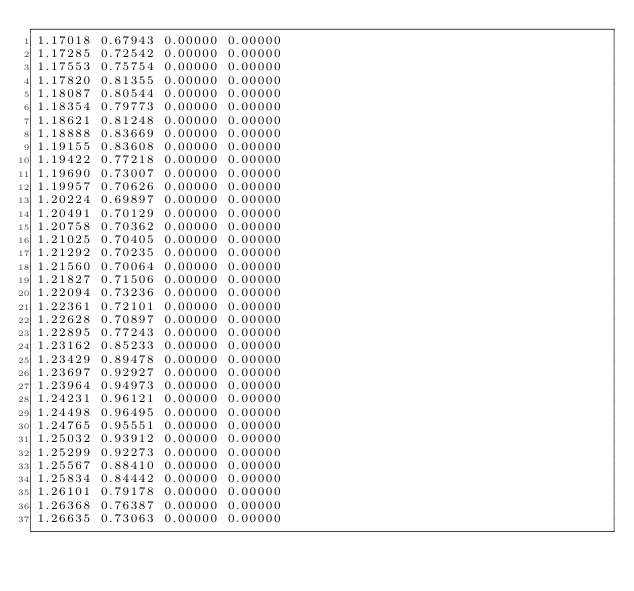Convert code to text. <code><loc_0><loc_0><loc_500><loc_500><_SQL_>1.17018 0.67943 0.00000 0.00000
1.17285 0.72542 0.00000 0.00000
1.17553 0.75754 0.00000 0.00000
1.17820 0.81355 0.00000 0.00000
1.18087 0.80544 0.00000 0.00000
1.18354 0.79773 0.00000 0.00000
1.18621 0.81248 0.00000 0.00000
1.18888 0.83669 0.00000 0.00000
1.19155 0.83608 0.00000 0.00000
1.19422 0.77218 0.00000 0.00000
1.19690 0.73007 0.00000 0.00000
1.19957 0.70626 0.00000 0.00000
1.20224 0.69897 0.00000 0.00000
1.20491 0.70129 0.00000 0.00000
1.20758 0.70362 0.00000 0.00000
1.21025 0.70405 0.00000 0.00000
1.21292 0.70235 0.00000 0.00000
1.21560 0.70064 0.00000 0.00000
1.21827 0.71506 0.00000 0.00000
1.22094 0.73236 0.00000 0.00000
1.22361 0.72101 0.00000 0.00000
1.22628 0.70897 0.00000 0.00000
1.22895 0.77243 0.00000 0.00000
1.23162 0.85233 0.00000 0.00000
1.23429 0.89478 0.00000 0.00000
1.23697 0.92927 0.00000 0.00000
1.23964 0.94973 0.00000 0.00000
1.24231 0.96121 0.00000 0.00000
1.24498 0.96495 0.00000 0.00000
1.24765 0.95551 0.00000 0.00000
1.25032 0.93912 0.00000 0.00000
1.25299 0.92273 0.00000 0.00000
1.25567 0.88410 0.00000 0.00000
1.25834 0.84442 0.00000 0.00000
1.26101 0.79178 0.00000 0.00000
1.26368 0.76387 0.00000 0.00000
1.26635 0.73063 0.00000 0.00000</code> 